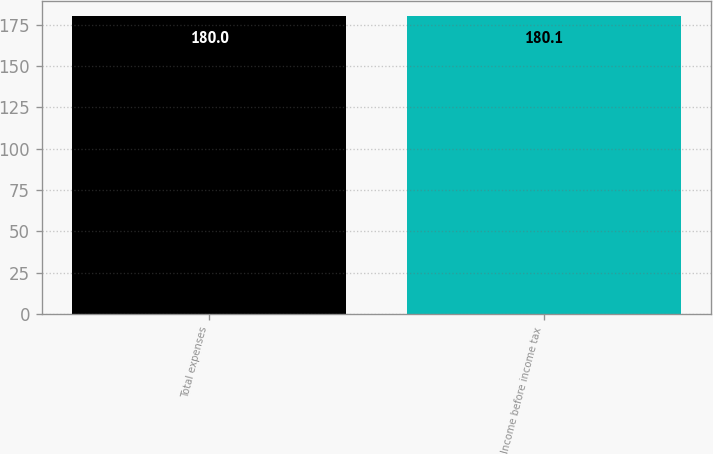Convert chart. <chart><loc_0><loc_0><loc_500><loc_500><bar_chart><fcel>Total expenses<fcel>Income before income tax<nl><fcel>180<fcel>180.1<nl></chart> 